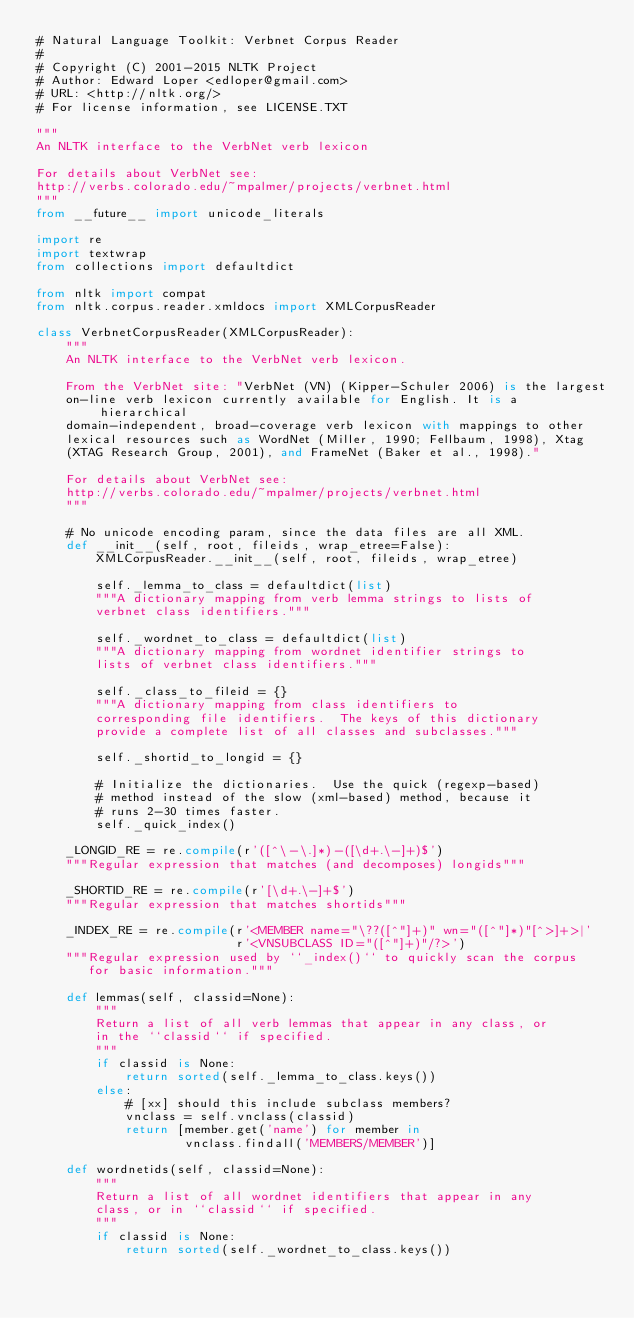<code> <loc_0><loc_0><loc_500><loc_500><_Python_># Natural Language Toolkit: Verbnet Corpus Reader
#
# Copyright (C) 2001-2015 NLTK Project
# Author: Edward Loper <edloper@gmail.com>
# URL: <http://nltk.org/>
# For license information, see LICENSE.TXT

"""
An NLTK interface to the VerbNet verb lexicon

For details about VerbNet see:
http://verbs.colorado.edu/~mpalmer/projects/verbnet.html
"""
from __future__ import unicode_literals

import re
import textwrap
from collections import defaultdict

from nltk import compat
from nltk.corpus.reader.xmldocs import XMLCorpusReader

class VerbnetCorpusReader(XMLCorpusReader):
    """
    An NLTK interface to the VerbNet verb lexicon.
    
    From the VerbNet site: "VerbNet (VN) (Kipper-Schuler 2006) is the largest 
    on-line verb lexicon currently available for English. It is a hierarchical 
    domain-independent, broad-coverage verb lexicon with mappings to other 
    lexical resources such as WordNet (Miller, 1990; Fellbaum, 1998), Xtag 
    (XTAG Research Group, 2001), and FrameNet (Baker et al., 1998)."

    For details about VerbNet see:
    http://verbs.colorado.edu/~mpalmer/projects/verbnet.html
    """

    # No unicode encoding param, since the data files are all XML.
    def __init__(self, root, fileids, wrap_etree=False):
        XMLCorpusReader.__init__(self, root, fileids, wrap_etree)

        self._lemma_to_class = defaultdict(list)
        """A dictionary mapping from verb lemma strings to lists of
        verbnet class identifiers."""

        self._wordnet_to_class = defaultdict(list)
        """A dictionary mapping from wordnet identifier strings to
        lists of verbnet class identifiers."""

        self._class_to_fileid = {}
        """A dictionary mapping from class identifiers to
        corresponding file identifiers.  The keys of this dictionary
        provide a complete list of all classes and subclasses."""

        self._shortid_to_longid = {}

        # Initialize the dictionaries.  Use the quick (regexp-based)
        # method instead of the slow (xml-based) method, because it
        # runs 2-30 times faster.
        self._quick_index()

    _LONGID_RE = re.compile(r'([^\-\.]*)-([\d+.\-]+)$')
    """Regular expression that matches (and decomposes) longids"""

    _SHORTID_RE = re.compile(r'[\d+.\-]+$')
    """Regular expression that matches shortids"""

    _INDEX_RE = re.compile(r'<MEMBER name="\??([^"]+)" wn="([^"]*)"[^>]+>|'
                           r'<VNSUBCLASS ID="([^"]+)"/?>')
    """Regular expression used by ``_index()`` to quickly scan the corpus
       for basic information."""

    def lemmas(self, classid=None):
        """
        Return a list of all verb lemmas that appear in any class, or
        in the ``classid`` if specified.
        """
        if classid is None:
            return sorted(self._lemma_to_class.keys())
        else:
            # [xx] should this include subclass members?
            vnclass = self.vnclass(classid)
            return [member.get('name') for member in
                    vnclass.findall('MEMBERS/MEMBER')]

    def wordnetids(self, classid=None):
        """
        Return a list of all wordnet identifiers that appear in any
        class, or in ``classid`` if specified.
        """
        if classid is None:
            return sorted(self._wordnet_to_class.keys())</code> 